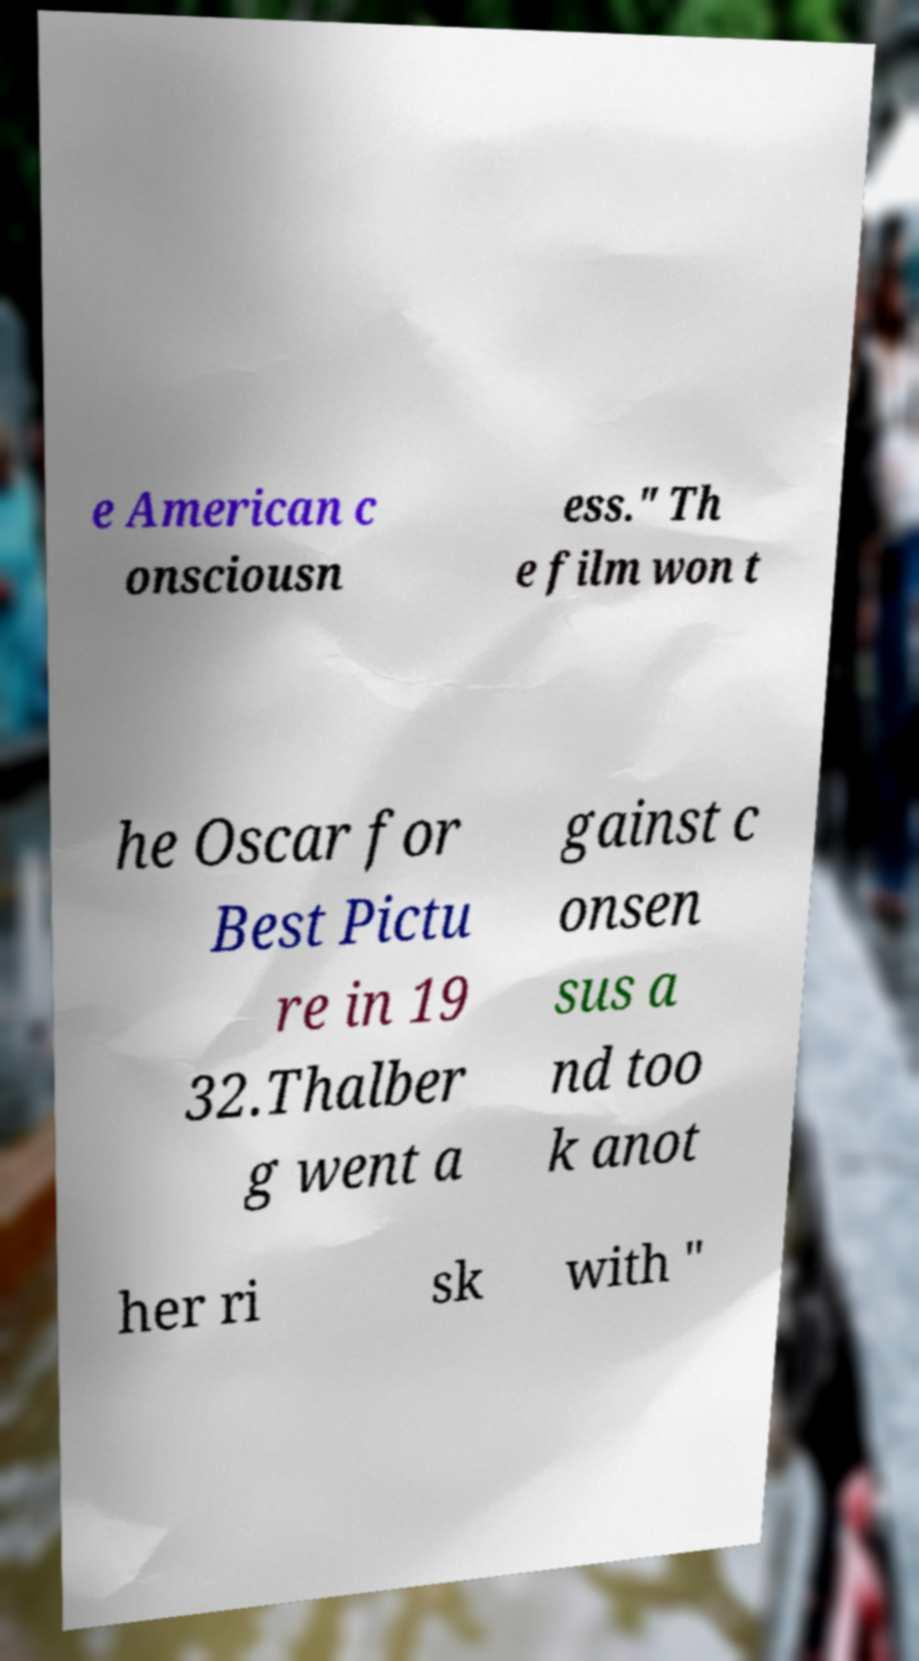I need the written content from this picture converted into text. Can you do that? e American c onsciousn ess." Th e film won t he Oscar for Best Pictu re in 19 32.Thalber g went a gainst c onsen sus a nd too k anot her ri sk with " 